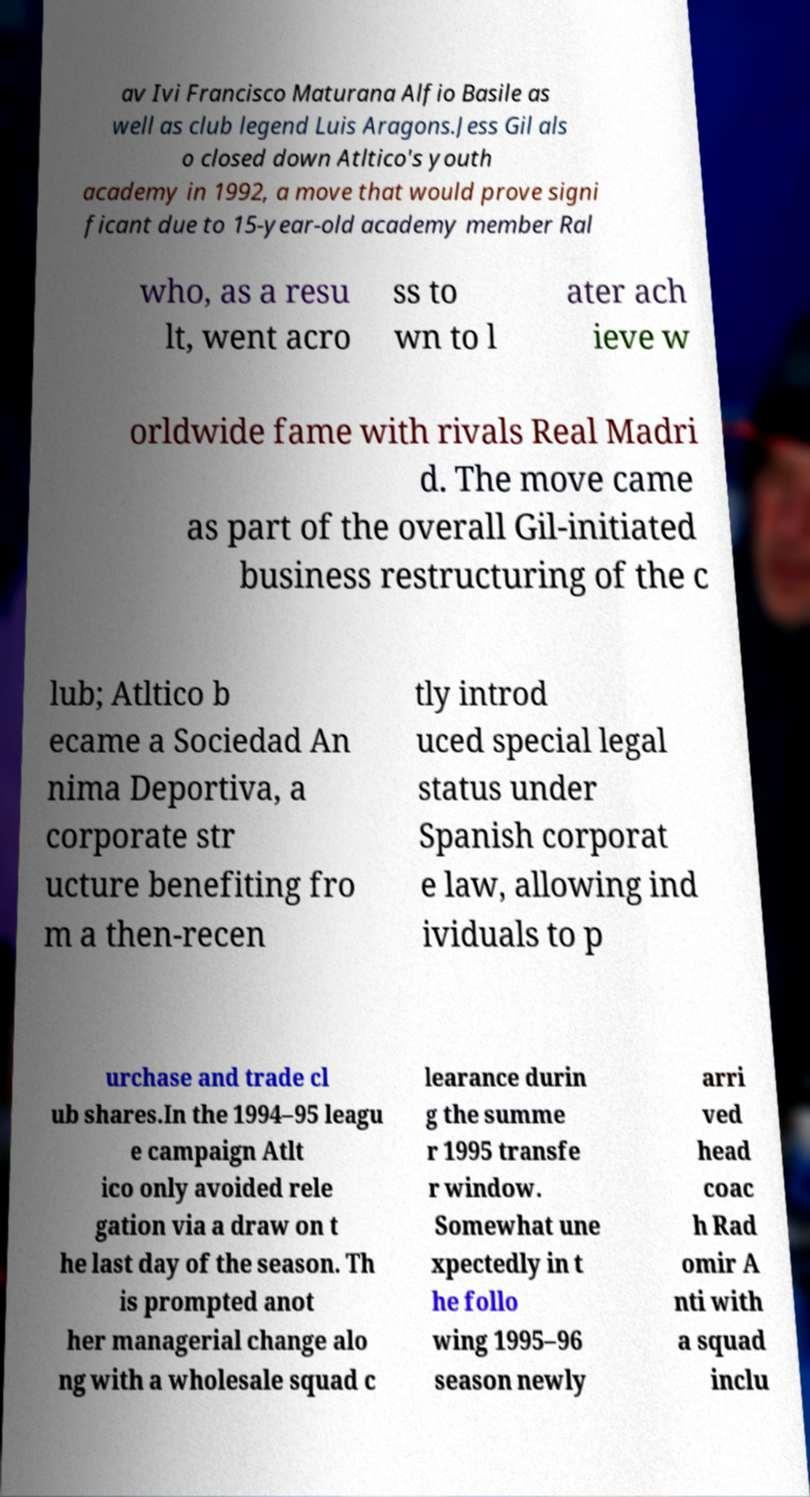There's text embedded in this image that I need extracted. Can you transcribe it verbatim? av Ivi Francisco Maturana Alfio Basile as well as club legend Luis Aragons.Jess Gil als o closed down Atltico's youth academy in 1992, a move that would prove signi ficant due to 15-year-old academy member Ral who, as a resu lt, went acro ss to wn to l ater ach ieve w orldwide fame with rivals Real Madri d. The move came as part of the overall Gil-initiated business restructuring of the c lub; Atltico b ecame a Sociedad An nima Deportiva, a corporate str ucture benefiting fro m a then-recen tly introd uced special legal status under Spanish corporat e law, allowing ind ividuals to p urchase and trade cl ub shares.In the 1994–95 leagu e campaign Atlt ico only avoided rele gation via a draw on t he last day of the season. Th is prompted anot her managerial change alo ng with a wholesale squad c learance durin g the summe r 1995 transfe r window. Somewhat une xpectedly in t he follo wing 1995–96 season newly arri ved head coac h Rad omir A nti with a squad inclu 